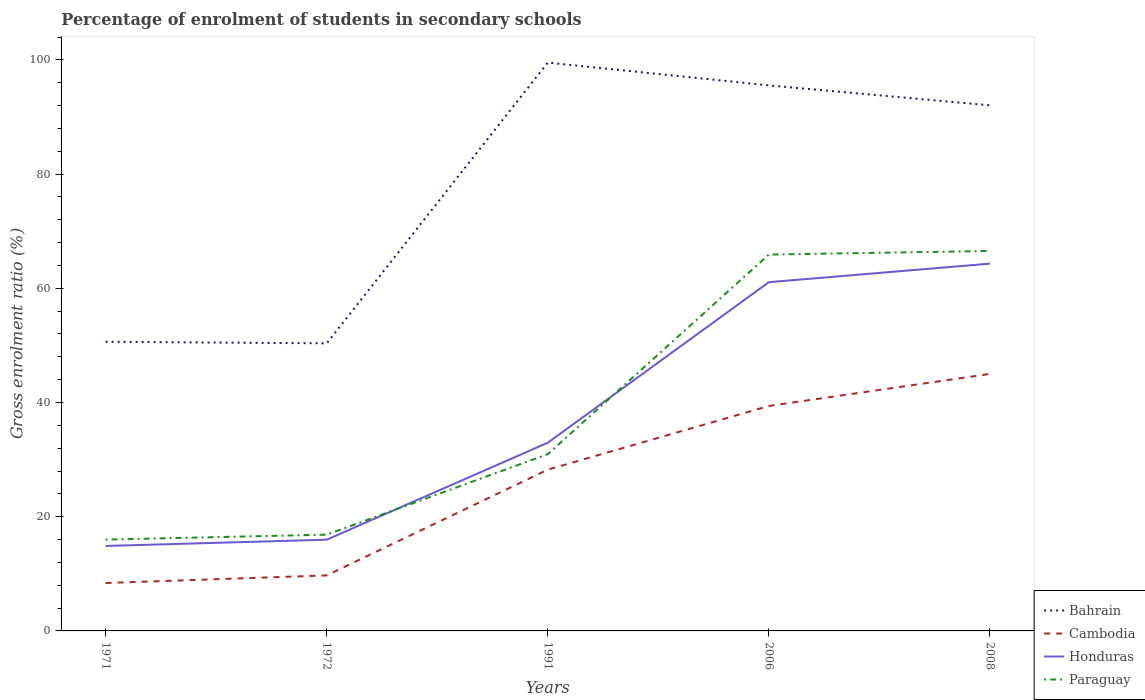How many different coloured lines are there?
Give a very brief answer. 4. Does the line corresponding to Honduras intersect with the line corresponding to Bahrain?
Provide a short and direct response. No. Is the number of lines equal to the number of legend labels?
Your response must be concise. Yes. Across all years, what is the maximum percentage of students enrolled in secondary schools in Paraguay?
Keep it short and to the point. 15.99. What is the total percentage of students enrolled in secondary schools in Paraguay in the graph?
Make the answer very short. -0.63. What is the difference between the highest and the second highest percentage of students enrolled in secondary schools in Bahrain?
Keep it short and to the point. 49.16. How many years are there in the graph?
Ensure brevity in your answer.  5. What is the difference between two consecutive major ticks on the Y-axis?
Ensure brevity in your answer.  20. Where does the legend appear in the graph?
Your answer should be very brief. Bottom right. How many legend labels are there?
Ensure brevity in your answer.  4. What is the title of the graph?
Offer a very short reply. Percentage of enrolment of students in secondary schools. What is the Gross enrolment ratio (%) of Bahrain in 1971?
Your answer should be very brief. 50.63. What is the Gross enrolment ratio (%) in Cambodia in 1971?
Keep it short and to the point. 8.39. What is the Gross enrolment ratio (%) in Honduras in 1971?
Provide a succinct answer. 14.88. What is the Gross enrolment ratio (%) of Paraguay in 1971?
Keep it short and to the point. 15.99. What is the Gross enrolment ratio (%) in Bahrain in 1972?
Offer a terse response. 50.36. What is the Gross enrolment ratio (%) in Cambodia in 1972?
Your answer should be compact. 9.72. What is the Gross enrolment ratio (%) of Honduras in 1972?
Provide a succinct answer. 15.97. What is the Gross enrolment ratio (%) of Paraguay in 1972?
Make the answer very short. 16.86. What is the Gross enrolment ratio (%) of Bahrain in 1991?
Give a very brief answer. 99.52. What is the Gross enrolment ratio (%) of Cambodia in 1991?
Give a very brief answer. 28.24. What is the Gross enrolment ratio (%) in Honduras in 1991?
Provide a succinct answer. 32.96. What is the Gross enrolment ratio (%) in Paraguay in 1991?
Provide a succinct answer. 30.95. What is the Gross enrolment ratio (%) in Bahrain in 2006?
Make the answer very short. 95.53. What is the Gross enrolment ratio (%) in Cambodia in 2006?
Your answer should be compact. 39.39. What is the Gross enrolment ratio (%) of Honduras in 2006?
Provide a short and direct response. 61.07. What is the Gross enrolment ratio (%) in Paraguay in 2006?
Keep it short and to the point. 65.9. What is the Gross enrolment ratio (%) in Bahrain in 2008?
Provide a succinct answer. 92.04. What is the Gross enrolment ratio (%) of Cambodia in 2008?
Give a very brief answer. 45.01. What is the Gross enrolment ratio (%) in Honduras in 2008?
Provide a short and direct response. 64.31. What is the Gross enrolment ratio (%) in Paraguay in 2008?
Your response must be concise. 66.53. Across all years, what is the maximum Gross enrolment ratio (%) in Bahrain?
Offer a terse response. 99.52. Across all years, what is the maximum Gross enrolment ratio (%) of Cambodia?
Your answer should be very brief. 45.01. Across all years, what is the maximum Gross enrolment ratio (%) of Honduras?
Your answer should be very brief. 64.31. Across all years, what is the maximum Gross enrolment ratio (%) of Paraguay?
Ensure brevity in your answer.  66.53. Across all years, what is the minimum Gross enrolment ratio (%) in Bahrain?
Your response must be concise. 50.36. Across all years, what is the minimum Gross enrolment ratio (%) of Cambodia?
Offer a terse response. 8.39. Across all years, what is the minimum Gross enrolment ratio (%) of Honduras?
Provide a succinct answer. 14.88. Across all years, what is the minimum Gross enrolment ratio (%) in Paraguay?
Offer a very short reply. 15.99. What is the total Gross enrolment ratio (%) of Bahrain in the graph?
Your answer should be compact. 388.07. What is the total Gross enrolment ratio (%) in Cambodia in the graph?
Your answer should be compact. 130.75. What is the total Gross enrolment ratio (%) in Honduras in the graph?
Keep it short and to the point. 189.19. What is the total Gross enrolment ratio (%) of Paraguay in the graph?
Provide a short and direct response. 196.24. What is the difference between the Gross enrolment ratio (%) in Bahrain in 1971 and that in 1972?
Provide a succinct answer. 0.28. What is the difference between the Gross enrolment ratio (%) of Cambodia in 1971 and that in 1972?
Your answer should be compact. -1.33. What is the difference between the Gross enrolment ratio (%) of Honduras in 1971 and that in 1972?
Offer a very short reply. -1.09. What is the difference between the Gross enrolment ratio (%) in Paraguay in 1971 and that in 1972?
Your answer should be compact. -0.87. What is the difference between the Gross enrolment ratio (%) in Bahrain in 1971 and that in 1991?
Ensure brevity in your answer.  -48.89. What is the difference between the Gross enrolment ratio (%) in Cambodia in 1971 and that in 1991?
Make the answer very short. -19.85. What is the difference between the Gross enrolment ratio (%) of Honduras in 1971 and that in 1991?
Your response must be concise. -18.08. What is the difference between the Gross enrolment ratio (%) of Paraguay in 1971 and that in 1991?
Offer a very short reply. -14.96. What is the difference between the Gross enrolment ratio (%) of Bahrain in 1971 and that in 2006?
Give a very brief answer. -44.89. What is the difference between the Gross enrolment ratio (%) in Cambodia in 1971 and that in 2006?
Offer a very short reply. -31. What is the difference between the Gross enrolment ratio (%) of Honduras in 1971 and that in 2006?
Ensure brevity in your answer.  -46.19. What is the difference between the Gross enrolment ratio (%) of Paraguay in 1971 and that in 2006?
Keep it short and to the point. -49.91. What is the difference between the Gross enrolment ratio (%) in Bahrain in 1971 and that in 2008?
Your answer should be very brief. -41.4. What is the difference between the Gross enrolment ratio (%) in Cambodia in 1971 and that in 2008?
Offer a very short reply. -36.62. What is the difference between the Gross enrolment ratio (%) of Honduras in 1971 and that in 2008?
Keep it short and to the point. -49.43. What is the difference between the Gross enrolment ratio (%) in Paraguay in 1971 and that in 2008?
Offer a terse response. -50.54. What is the difference between the Gross enrolment ratio (%) of Bahrain in 1972 and that in 1991?
Your answer should be compact. -49.16. What is the difference between the Gross enrolment ratio (%) in Cambodia in 1972 and that in 1991?
Provide a succinct answer. -18.52. What is the difference between the Gross enrolment ratio (%) in Honduras in 1972 and that in 1991?
Provide a succinct answer. -16.98. What is the difference between the Gross enrolment ratio (%) of Paraguay in 1972 and that in 1991?
Your answer should be compact. -14.09. What is the difference between the Gross enrolment ratio (%) in Bahrain in 1972 and that in 2006?
Give a very brief answer. -45.17. What is the difference between the Gross enrolment ratio (%) in Cambodia in 1972 and that in 2006?
Offer a terse response. -29.67. What is the difference between the Gross enrolment ratio (%) in Honduras in 1972 and that in 2006?
Offer a very short reply. -45.09. What is the difference between the Gross enrolment ratio (%) in Paraguay in 1972 and that in 2006?
Provide a short and direct response. -49.05. What is the difference between the Gross enrolment ratio (%) of Bahrain in 1972 and that in 2008?
Provide a succinct answer. -41.68. What is the difference between the Gross enrolment ratio (%) of Cambodia in 1972 and that in 2008?
Your response must be concise. -35.28. What is the difference between the Gross enrolment ratio (%) of Honduras in 1972 and that in 2008?
Provide a short and direct response. -48.34. What is the difference between the Gross enrolment ratio (%) of Paraguay in 1972 and that in 2008?
Offer a very short reply. -49.68. What is the difference between the Gross enrolment ratio (%) in Bahrain in 1991 and that in 2006?
Provide a succinct answer. 3.99. What is the difference between the Gross enrolment ratio (%) of Cambodia in 1991 and that in 2006?
Provide a succinct answer. -11.15. What is the difference between the Gross enrolment ratio (%) in Honduras in 1991 and that in 2006?
Offer a very short reply. -28.11. What is the difference between the Gross enrolment ratio (%) of Paraguay in 1991 and that in 2006?
Offer a very short reply. -34.95. What is the difference between the Gross enrolment ratio (%) in Bahrain in 1991 and that in 2008?
Provide a succinct answer. 7.48. What is the difference between the Gross enrolment ratio (%) of Cambodia in 1991 and that in 2008?
Your answer should be compact. -16.77. What is the difference between the Gross enrolment ratio (%) in Honduras in 1991 and that in 2008?
Make the answer very short. -31.36. What is the difference between the Gross enrolment ratio (%) of Paraguay in 1991 and that in 2008?
Your response must be concise. -35.58. What is the difference between the Gross enrolment ratio (%) of Bahrain in 2006 and that in 2008?
Your answer should be compact. 3.49. What is the difference between the Gross enrolment ratio (%) in Cambodia in 2006 and that in 2008?
Make the answer very short. -5.62. What is the difference between the Gross enrolment ratio (%) of Honduras in 2006 and that in 2008?
Ensure brevity in your answer.  -3.25. What is the difference between the Gross enrolment ratio (%) in Paraguay in 2006 and that in 2008?
Offer a very short reply. -0.63. What is the difference between the Gross enrolment ratio (%) in Bahrain in 1971 and the Gross enrolment ratio (%) in Cambodia in 1972?
Your answer should be very brief. 40.91. What is the difference between the Gross enrolment ratio (%) of Bahrain in 1971 and the Gross enrolment ratio (%) of Honduras in 1972?
Your answer should be compact. 34.66. What is the difference between the Gross enrolment ratio (%) in Bahrain in 1971 and the Gross enrolment ratio (%) in Paraguay in 1972?
Make the answer very short. 33.78. What is the difference between the Gross enrolment ratio (%) of Cambodia in 1971 and the Gross enrolment ratio (%) of Honduras in 1972?
Your answer should be very brief. -7.59. What is the difference between the Gross enrolment ratio (%) of Cambodia in 1971 and the Gross enrolment ratio (%) of Paraguay in 1972?
Offer a terse response. -8.47. What is the difference between the Gross enrolment ratio (%) in Honduras in 1971 and the Gross enrolment ratio (%) in Paraguay in 1972?
Give a very brief answer. -1.98. What is the difference between the Gross enrolment ratio (%) of Bahrain in 1971 and the Gross enrolment ratio (%) of Cambodia in 1991?
Your response must be concise. 22.4. What is the difference between the Gross enrolment ratio (%) of Bahrain in 1971 and the Gross enrolment ratio (%) of Honduras in 1991?
Give a very brief answer. 17.68. What is the difference between the Gross enrolment ratio (%) in Bahrain in 1971 and the Gross enrolment ratio (%) in Paraguay in 1991?
Provide a short and direct response. 19.68. What is the difference between the Gross enrolment ratio (%) of Cambodia in 1971 and the Gross enrolment ratio (%) of Honduras in 1991?
Offer a terse response. -24.57. What is the difference between the Gross enrolment ratio (%) in Cambodia in 1971 and the Gross enrolment ratio (%) in Paraguay in 1991?
Keep it short and to the point. -22.56. What is the difference between the Gross enrolment ratio (%) in Honduras in 1971 and the Gross enrolment ratio (%) in Paraguay in 1991?
Ensure brevity in your answer.  -16.07. What is the difference between the Gross enrolment ratio (%) of Bahrain in 1971 and the Gross enrolment ratio (%) of Cambodia in 2006?
Your response must be concise. 11.24. What is the difference between the Gross enrolment ratio (%) of Bahrain in 1971 and the Gross enrolment ratio (%) of Honduras in 2006?
Offer a terse response. -10.43. What is the difference between the Gross enrolment ratio (%) of Bahrain in 1971 and the Gross enrolment ratio (%) of Paraguay in 2006?
Give a very brief answer. -15.27. What is the difference between the Gross enrolment ratio (%) of Cambodia in 1971 and the Gross enrolment ratio (%) of Honduras in 2006?
Offer a terse response. -52.68. What is the difference between the Gross enrolment ratio (%) of Cambodia in 1971 and the Gross enrolment ratio (%) of Paraguay in 2006?
Offer a terse response. -57.52. What is the difference between the Gross enrolment ratio (%) of Honduras in 1971 and the Gross enrolment ratio (%) of Paraguay in 2006?
Give a very brief answer. -51.02. What is the difference between the Gross enrolment ratio (%) of Bahrain in 1971 and the Gross enrolment ratio (%) of Cambodia in 2008?
Your answer should be compact. 5.63. What is the difference between the Gross enrolment ratio (%) in Bahrain in 1971 and the Gross enrolment ratio (%) in Honduras in 2008?
Offer a very short reply. -13.68. What is the difference between the Gross enrolment ratio (%) in Bahrain in 1971 and the Gross enrolment ratio (%) in Paraguay in 2008?
Give a very brief answer. -15.9. What is the difference between the Gross enrolment ratio (%) in Cambodia in 1971 and the Gross enrolment ratio (%) in Honduras in 2008?
Make the answer very short. -55.93. What is the difference between the Gross enrolment ratio (%) of Cambodia in 1971 and the Gross enrolment ratio (%) of Paraguay in 2008?
Make the answer very short. -58.15. What is the difference between the Gross enrolment ratio (%) of Honduras in 1971 and the Gross enrolment ratio (%) of Paraguay in 2008?
Offer a terse response. -51.65. What is the difference between the Gross enrolment ratio (%) in Bahrain in 1972 and the Gross enrolment ratio (%) in Cambodia in 1991?
Keep it short and to the point. 22.12. What is the difference between the Gross enrolment ratio (%) in Bahrain in 1972 and the Gross enrolment ratio (%) in Honduras in 1991?
Give a very brief answer. 17.4. What is the difference between the Gross enrolment ratio (%) in Bahrain in 1972 and the Gross enrolment ratio (%) in Paraguay in 1991?
Ensure brevity in your answer.  19.41. What is the difference between the Gross enrolment ratio (%) in Cambodia in 1972 and the Gross enrolment ratio (%) in Honduras in 1991?
Offer a very short reply. -23.23. What is the difference between the Gross enrolment ratio (%) of Cambodia in 1972 and the Gross enrolment ratio (%) of Paraguay in 1991?
Provide a succinct answer. -21.23. What is the difference between the Gross enrolment ratio (%) in Honduras in 1972 and the Gross enrolment ratio (%) in Paraguay in 1991?
Your answer should be compact. -14.98. What is the difference between the Gross enrolment ratio (%) in Bahrain in 1972 and the Gross enrolment ratio (%) in Cambodia in 2006?
Offer a terse response. 10.97. What is the difference between the Gross enrolment ratio (%) in Bahrain in 1972 and the Gross enrolment ratio (%) in Honduras in 2006?
Make the answer very short. -10.71. What is the difference between the Gross enrolment ratio (%) in Bahrain in 1972 and the Gross enrolment ratio (%) in Paraguay in 2006?
Offer a very short reply. -15.55. What is the difference between the Gross enrolment ratio (%) in Cambodia in 1972 and the Gross enrolment ratio (%) in Honduras in 2006?
Ensure brevity in your answer.  -51.35. What is the difference between the Gross enrolment ratio (%) in Cambodia in 1972 and the Gross enrolment ratio (%) in Paraguay in 2006?
Give a very brief answer. -56.18. What is the difference between the Gross enrolment ratio (%) in Honduras in 1972 and the Gross enrolment ratio (%) in Paraguay in 2006?
Provide a short and direct response. -49.93. What is the difference between the Gross enrolment ratio (%) in Bahrain in 1972 and the Gross enrolment ratio (%) in Cambodia in 2008?
Offer a very short reply. 5.35. What is the difference between the Gross enrolment ratio (%) in Bahrain in 1972 and the Gross enrolment ratio (%) in Honduras in 2008?
Ensure brevity in your answer.  -13.96. What is the difference between the Gross enrolment ratio (%) in Bahrain in 1972 and the Gross enrolment ratio (%) in Paraguay in 2008?
Offer a very short reply. -16.18. What is the difference between the Gross enrolment ratio (%) in Cambodia in 1972 and the Gross enrolment ratio (%) in Honduras in 2008?
Keep it short and to the point. -54.59. What is the difference between the Gross enrolment ratio (%) of Cambodia in 1972 and the Gross enrolment ratio (%) of Paraguay in 2008?
Keep it short and to the point. -56.81. What is the difference between the Gross enrolment ratio (%) in Honduras in 1972 and the Gross enrolment ratio (%) in Paraguay in 2008?
Offer a very short reply. -50.56. What is the difference between the Gross enrolment ratio (%) in Bahrain in 1991 and the Gross enrolment ratio (%) in Cambodia in 2006?
Ensure brevity in your answer.  60.13. What is the difference between the Gross enrolment ratio (%) in Bahrain in 1991 and the Gross enrolment ratio (%) in Honduras in 2006?
Ensure brevity in your answer.  38.45. What is the difference between the Gross enrolment ratio (%) in Bahrain in 1991 and the Gross enrolment ratio (%) in Paraguay in 2006?
Your answer should be very brief. 33.62. What is the difference between the Gross enrolment ratio (%) of Cambodia in 1991 and the Gross enrolment ratio (%) of Honduras in 2006?
Provide a succinct answer. -32.83. What is the difference between the Gross enrolment ratio (%) in Cambodia in 1991 and the Gross enrolment ratio (%) in Paraguay in 2006?
Your answer should be very brief. -37.66. What is the difference between the Gross enrolment ratio (%) in Honduras in 1991 and the Gross enrolment ratio (%) in Paraguay in 2006?
Give a very brief answer. -32.95. What is the difference between the Gross enrolment ratio (%) of Bahrain in 1991 and the Gross enrolment ratio (%) of Cambodia in 2008?
Offer a terse response. 54.51. What is the difference between the Gross enrolment ratio (%) in Bahrain in 1991 and the Gross enrolment ratio (%) in Honduras in 2008?
Ensure brevity in your answer.  35.21. What is the difference between the Gross enrolment ratio (%) of Bahrain in 1991 and the Gross enrolment ratio (%) of Paraguay in 2008?
Ensure brevity in your answer.  32.99. What is the difference between the Gross enrolment ratio (%) in Cambodia in 1991 and the Gross enrolment ratio (%) in Honduras in 2008?
Give a very brief answer. -36.07. What is the difference between the Gross enrolment ratio (%) of Cambodia in 1991 and the Gross enrolment ratio (%) of Paraguay in 2008?
Offer a very short reply. -38.29. What is the difference between the Gross enrolment ratio (%) in Honduras in 1991 and the Gross enrolment ratio (%) in Paraguay in 2008?
Your answer should be very brief. -33.58. What is the difference between the Gross enrolment ratio (%) of Bahrain in 2006 and the Gross enrolment ratio (%) of Cambodia in 2008?
Keep it short and to the point. 50.52. What is the difference between the Gross enrolment ratio (%) in Bahrain in 2006 and the Gross enrolment ratio (%) in Honduras in 2008?
Provide a short and direct response. 31.21. What is the difference between the Gross enrolment ratio (%) in Bahrain in 2006 and the Gross enrolment ratio (%) in Paraguay in 2008?
Provide a short and direct response. 28.99. What is the difference between the Gross enrolment ratio (%) of Cambodia in 2006 and the Gross enrolment ratio (%) of Honduras in 2008?
Your response must be concise. -24.92. What is the difference between the Gross enrolment ratio (%) of Cambodia in 2006 and the Gross enrolment ratio (%) of Paraguay in 2008?
Your response must be concise. -27.14. What is the difference between the Gross enrolment ratio (%) of Honduras in 2006 and the Gross enrolment ratio (%) of Paraguay in 2008?
Your answer should be compact. -5.47. What is the average Gross enrolment ratio (%) in Bahrain per year?
Provide a succinct answer. 77.61. What is the average Gross enrolment ratio (%) of Cambodia per year?
Make the answer very short. 26.15. What is the average Gross enrolment ratio (%) of Honduras per year?
Keep it short and to the point. 37.84. What is the average Gross enrolment ratio (%) of Paraguay per year?
Provide a succinct answer. 39.25. In the year 1971, what is the difference between the Gross enrolment ratio (%) of Bahrain and Gross enrolment ratio (%) of Cambodia?
Your response must be concise. 42.25. In the year 1971, what is the difference between the Gross enrolment ratio (%) in Bahrain and Gross enrolment ratio (%) in Honduras?
Your answer should be compact. 35.75. In the year 1971, what is the difference between the Gross enrolment ratio (%) in Bahrain and Gross enrolment ratio (%) in Paraguay?
Offer a terse response. 34.64. In the year 1971, what is the difference between the Gross enrolment ratio (%) in Cambodia and Gross enrolment ratio (%) in Honduras?
Give a very brief answer. -6.49. In the year 1971, what is the difference between the Gross enrolment ratio (%) in Cambodia and Gross enrolment ratio (%) in Paraguay?
Provide a short and direct response. -7.6. In the year 1971, what is the difference between the Gross enrolment ratio (%) of Honduras and Gross enrolment ratio (%) of Paraguay?
Give a very brief answer. -1.11. In the year 1972, what is the difference between the Gross enrolment ratio (%) in Bahrain and Gross enrolment ratio (%) in Cambodia?
Your answer should be very brief. 40.64. In the year 1972, what is the difference between the Gross enrolment ratio (%) of Bahrain and Gross enrolment ratio (%) of Honduras?
Provide a short and direct response. 34.38. In the year 1972, what is the difference between the Gross enrolment ratio (%) of Bahrain and Gross enrolment ratio (%) of Paraguay?
Offer a terse response. 33.5. In the year 1972, what is the difference between the Gross enrolment ratio (%) of Cambodia and Gross enrolment ratio (%) of Honduras?
Keep it short and to the point. -6.25. In the year 1972, what is the difference between the Gross enrolment ratio (%) of Cambodia and Gross enrolment ratio (%) of Paraguay?
Give a very brief answer. -7.14. In the year 1972, what is the difference between the Gross enrolment ratio (%) in Honduras and Gross enrolment ratio (%) in Paraguay?
Offer a very short reply. -0.88. In the year 1991, what is the difference between the Gross enrolment ratio (%) in Bahrain and Gross enrolment ratio (%) in Cambodia?
Keep it short and to the point. 71.28. In the year 1991, what is the difference between the Gross enrolment ratio (%) in Bahrain and Gross enrolment ratio (%) in Honduras?
Your answer should be compact. 66.56. In the year 1991, what is the difference between the Gross enrolment ratio (%) in Bahrain and Gross enrolment ratio (%) in Paraguay?
Offer a very short reply. 68.57. In the year 1991, what is the difference between the Gross enrolment ratio (%) of Cambodia and Gross enrolment ratio (%) of Honduras?
Give a very brief answer. -4.72. In the year 1991, what is the difference between the Gross enrolment ratio (%) of Cambodia and Gross enrolment ratio (%) of Paraguay?
Ensure brevity in your answer.  -2.71. In the year 1991, what is the difference between the Gross enrolment ratio (%) in Honduras and Gross enrolment ratio (%) in Paraguay?
Your answer should be very brief. 2. In the year 2006, what is the difference between the Gross enrolment ratio (%) in Bahrain and Gross enrolment ratio (%) in Cambodia?
Provide a short and direct response. 56.13. In the year 2006, what is the difference between the Gross enrolment ratio (%) in Bahrain and Gross enrolment ratio (%) in Honduras?
Provide a succinct answer. 34.46. In the year 2006, what is the difference between the Gross enrolment ratio (%) of Bahrain and Gross enrolment ratio (%) of Paraguay?
Offer a very short reply. 29.62. In the year 2006, what is the difference between the Gross enrolment ratio (%) of Cambodia and Gross enrolment ratio (%) of Honduras?
Provide a succinct answer. -21.68. In the year 2006, what is the difference between the Gross enrolment ratio (%) in Cambodia and Gross enrolment ratio (%) in Paraguay?
Ensure brevity in your answer.  -26.51. In the year 2006, what is the difference between the Gross enrolment ratio (%) in Honduras and Gross enrolment ratio (%) in Paraguay?
Provide a succinct answer. -4.84. In the year 2008, what is the difference between the Gross enrolment ratio (%) in Bahrain and Gross enrolment ratio (%) in Cambodia?
Make the answer very short. 47.03. In the year 2008, what is the difference between the Gross enrolment ratio (%) of Bahrain and Gross enrolment ratio (%) of Honduras?
Make the answer very short. 27.72. In the year 2008, what is the difference between the Gross enrolment ratio (%) of Bahrain and Gross enrolment ratio (%) of Paraguay?
Your answer should be very brief. 25.5. In the year 2008, what is the difference between the Gross enrolment ratio (%) of Cambodia and Gross enrolment ratio (%) of Honduras?
Your response must be concise. -19.31. In the year 2008, what is the difference between the Gross enrolment ratio (%) of Cambodia and Gross enrolment ratio (%) of Paraguay?
Offer a very short reply. -21.53. In the year 2008, what is the difference between the Gross enrolment ratio (%) of Honduras and Gross enrolment ratio (%) of Paraguay?
Offer a very short reply. -2.22. What is the ratio of the Gross enrolment ratio (%) of Cambodia in 1971 to that in 1972?
Your answer should be compact. 0.86. What is the ratio of the Gross enrolment ratio (%) of Honduras in 1971 to that in 1972?
Your answer should be very brief. 0.93. What is the ratio of the Gross enrolment ratio (%) of Paraguay in 1971 to that in 1972?
Provide a short and direct response. 0.95. What is the ratio of the Gross enrolment ratio (%) of Bahrain in 1971 to that in 1991?
Offer a terse response. 0.51. What is the ratio of the Gross enrolment ratio (%) of Cambodia in 1971 to that in 1991?
Keep it short and to the point. 0.3. What is the ratio of the Gross enrolment ratio (%) of Honduras in 1971 to that in 1991?
Offer a very short reply. 0.45. What is the ratio of the Gross enrolment ratio (%) in Paraguay in 1971 to that in 1991?
Offer a very short reply. 0.52. What is the ratio of the Gross enrolment ratio (%) of Bahrain in 1971 to that in 2006?
Your answer should be very brief. 0.53. What is the ratio of the Gross enrolment ratio (%) in Cambodia in 1971 to that in 2006?
Give a very brief answer. 0.21. What is the ratio of the Gross enrolment ratio (%) in Honduras in 1971 to that in 2006?
Provide a succinct answer. 0.24. What is the ratio of the Gross enrolment ratio (%) of Paraguay in 1971 to that in 2006?
Your response must be concise. 0.24. What is the ratio of the Gross enrolment ratio (%) of Bahrain in 1971 to that in 2008?
Provide a succinct answer. 0.55. What is the ratio of the Gross enrolment ratio (%) in Cambodia in 1971 to that in 2008?
Give a very brief answer. 0.19. What is the ratio of the Gross enrolment ratio (%) in Honduras in 1971 to that in 2008?
Provide a succinct answer. 0.23. What is the ratio of the Gross enrolment ratio (%) of Paraguay in 1971 to that in 2008?
Your response must be concise. 0.24. What is the ratio of the Gross enrolment ratio (%) in Bahrain in 1972 to that in 1991?
Your answer should be very brief. 0.51. What is the ratio of the Gross enrolment ratio (%) of Cambodia in 1972 to that in 1991?
Your response must be concise. 0.34. What is the ratio of the Gross enrolment ratio (%) in Honduras in 1972 to that in 1991?
Your answer should be very brief. 0.48. What is the ratio of the Gross enrolment ratio (%) in Paraguay in 1972 to that in 1991?
Ensure brevity in your answer.  0.54. What is the ratio of the Gross enrolment ratio (%) in Bahrain in 1972 to that in 2006?
Your response must be concise. 0.53. What is the ratio of the Gross enrolment ratio (%) of Cambodia in 1972 to that in 2006?
Provide a short and direct response. 0.25. What is the ratio of the Gross enrolment ratio (%) of Honduras in 1972 to that in 2006?
Ensure brevity in your answer.  0.26. What is the ratio of the Gross enrolment ratio (%) of Paraguay in 1972 to that in 2006?
Your answer should be very brief. 0.26. What is the ratio of the Gross enrolment ratio (%) in Bahrain in 1972 to that in 2008?
Your answer should be very brief. 0.55. What is the ratio of the Gross enrolment ratio (%) in Cambodia in 1972 to that in 2008?
Your answer should be compact. 0.22. What is the ratio of the Gross enrolment ratio (%) in Honduras in 1972 to that in 2008?
Provide a succinct answer. 0.25. What is the ratio of the Gross enrolment ratio (%) of Paraguay in 1972 to that in 2008?
Your response must be concise. 0.25. What is the ratio of the Gross enrolment ratio (%) of Bahrain in 1991 to that in 2006?
Your answer should be compact. 1.04. What is the ratio of the Gross enrolment ratio (%) of Cambodia in 1991 to that in 2006?
Make the answer very short. 0.72. What is the ratio of the Gross enrolment ratio (%) of Honduras in 1991 to that in 2006?
Give a very brief answer. 0.54. What is the ratio of the Gross enrolment ratio (%) of Paraguay in 1991 to that in 2006?
Provide a short and direct response. 0.47. What is the ratio of the Gross enrolment ratio (%) of Bahrain in 1991 to that in 2008?
Offer a very short reply. 1.08. What is the ratio of the Gross enrolment ratio (%) in Cambodia in 1991 to that in 2008?
Offer a very short reply. 0.63. What is the ratio of the Gross enrolment ratio (%) in Honduras in 1991 to that in 2008?
Offer a very short reply. 0.51. What is the ratio of the Gross enrolment ratio (%) in Paraguay in 1991 to that in 2008?
Offer a very short reply. 0.47. What is the ratio of the Gross enrolment ratio (%) in Bahrain in 2006 to that in 2008?
Your answer should be compact. 1.04. What is the ratio of the Gross enrolment ratio (%) of Cambodia in 2006 to that in 2008?
Provide a succinct answer. 0.88. What is the ratio of the Gross enrolment ratio (%) of Honduras in 2006 to that in 2008?
Your response must be concise. 0.95. What is the difference between the highest and the second highest Gross enrolment ratio (%) of Bahrain?
Your response must be concise. 3.99. What is the difference between the highest and the second highest Gross enrolment ratio (%) of Cambodia?
Ensure brevity in your answer.  5.62. What is the difference between the highest and the second highest Gross enrolment ratio (%) in Honduras?
Give a very brief answer. 3.25. What is the difference between the highest and the second highest Gross enrolment ratio (%) of Paraguay?
Offer a very short reply. 0.63. What is the difference between the highest and the lowest Gross enrolment ratio (%) in Bahrain?
Your answer should be compact. 49.16. What is the difference between the highest and the lowest Gross enrolment ratio (%) in Cambodia?
Offer a very short reply. 36.62. What is the difference between the highest and the lowest Gross enrolment ratio (%) of Honduras?
Ensure brevity in your answer.  49.43. What is the difference between the highest and the lowest Gross enrolment ratio (%) in Paraguay?
Provide a short and direct response. 50.54. 